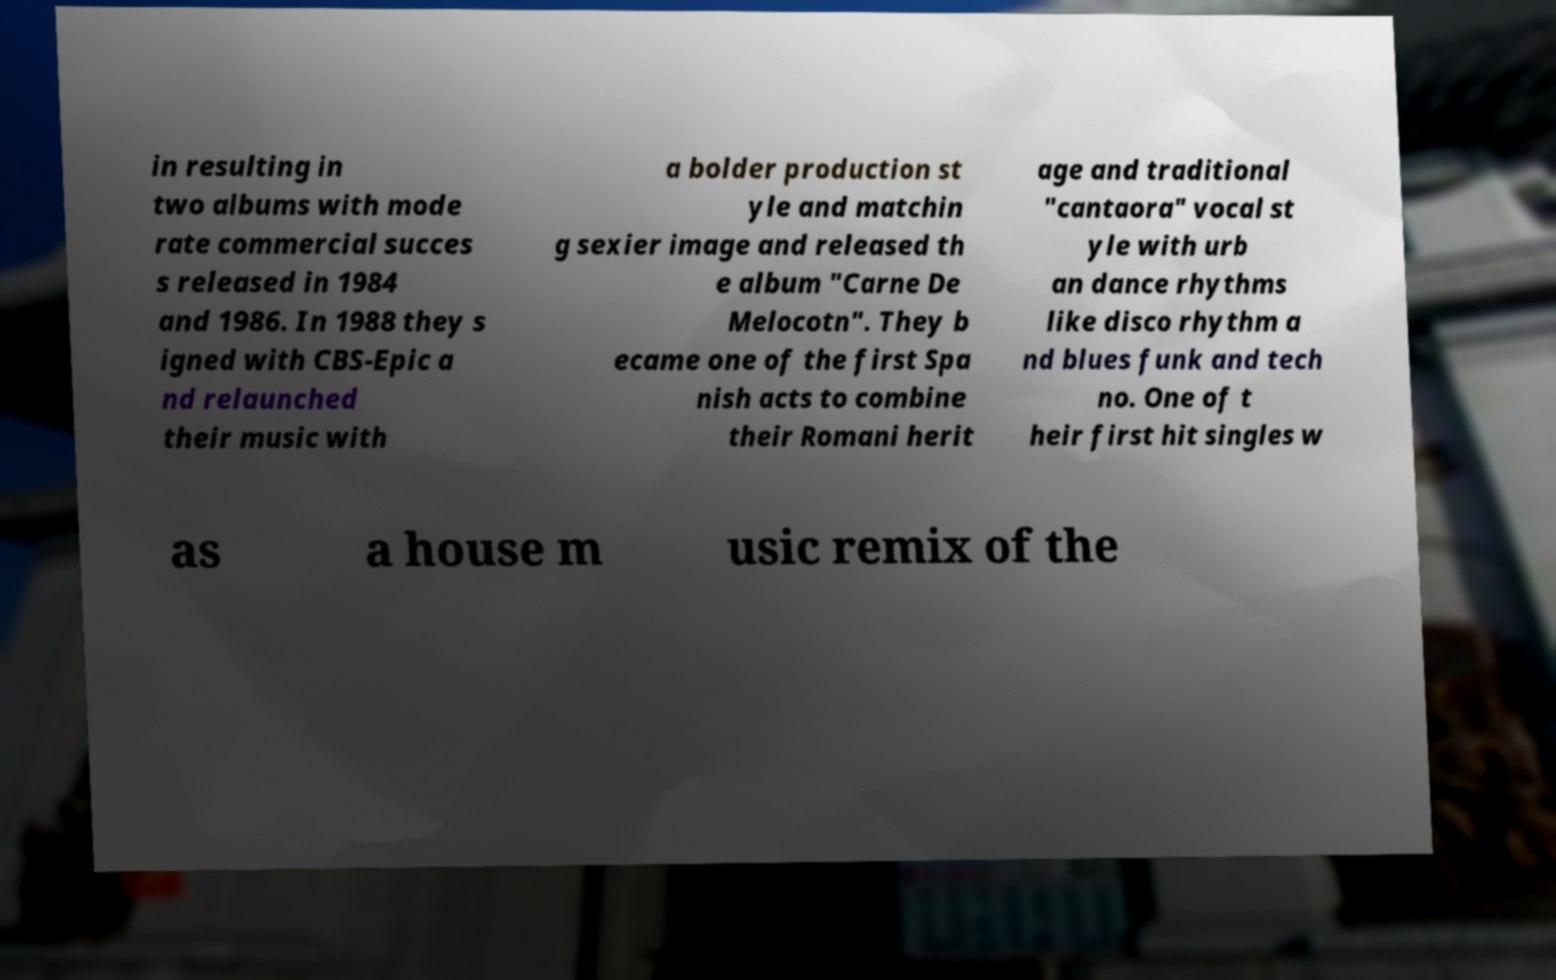Please read and relay the text visible in this image. What does it say? in resulting in two albums with mode rate commercial succes s released in 1984 and 1986. In 1988 they s igned with CBS-Epic a nd relaunched their music with a bolder production st yle and matchin g sexier image and released th e album "Carne De Melocotn". They b ecame one of the first Spa nish acts to combine their Romani herit age and traditional "cantaora" vocal st yle with urb an dance rhythms like disco rhythm a nd blues funk and tech no. One of t heir first hit singles w as a house m usic remix of the 